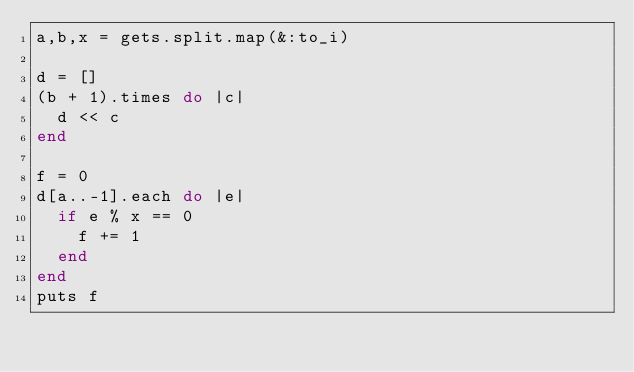<code> <loc_0><loc_0><loc_500><loc_500><_Ruby_>a,b,x = gets.split.map(&:to_i)

d = []
(b + 1).times do |c|
  d << c
end

f = 0
d[a..-1].each do |e|
  if e % x == 0
    f += 1
  end
end
puts f</code> 